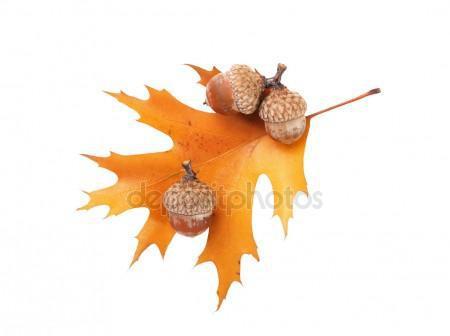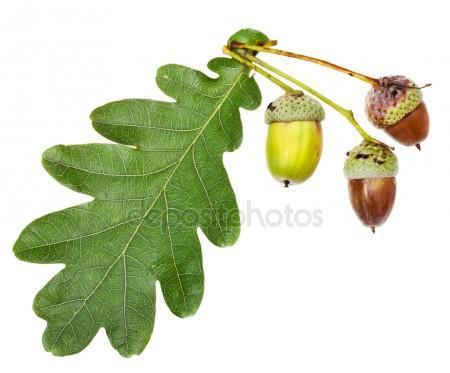The first image is the image on the left, the second image is the image on the right. Assess this claim about the two images: "The left and right image contains the same number of acorns.". Correct or not? Answer yes or no. Yes. The first image is the image on the left, the second image is the image on the right. For the images displayed, is the sentence "Each image shows at least two acorns and two acorn caps overlapping at least one green oak leaf." factually correct? Answer yes or no. No. 